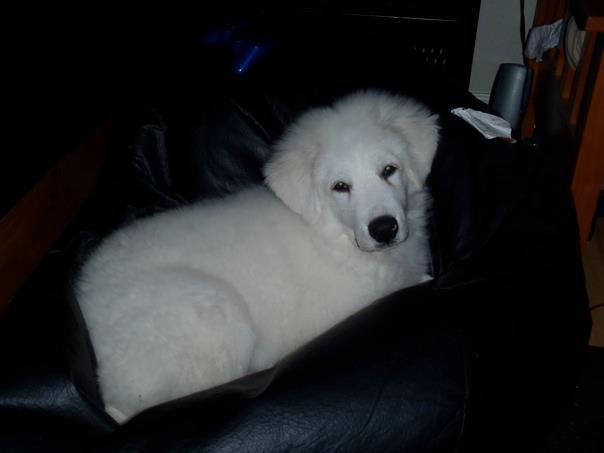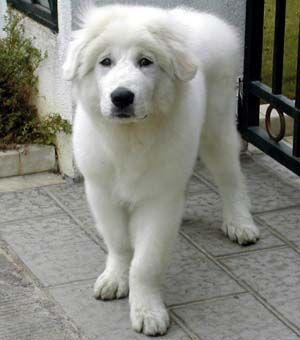The first image is the image on the left, the second image is the image on the right. Evaluate the accuracy of this statement regarding the images: "A person is holding a dog in one of the images.". Is it true? Answer yes or no. No. The first image is the image on the left, the second image is the image on the right. Examine the images to the left and right. Is the description "In one image a large white dog is being held by a man, while the second image shows a white dog sitting near a person." accurate? Answer yes or no. No. 